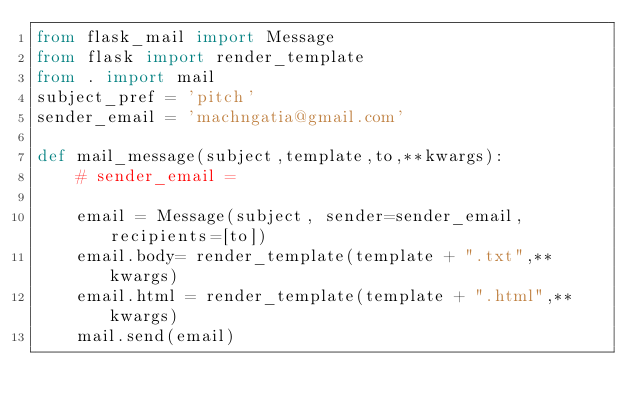<code> <loc_0><loc_0><loc_500><loc_500><_Python_>from flask_mail import Message
from flask import render_template
from . import mail
subject_pref = 'pitch'
sender_email = 'machngatia@gmail.com'

def mail_message(subject,template,to,**kwargs):
    # sender_email = 

    email = Message(subject, sender=sender_email, recipients=[to])
    email.body= render_template(template + ".txt",**kwargs)
    email.html = render_template(template + ".html",**kwargs)
    mail.send(email)
</code> 